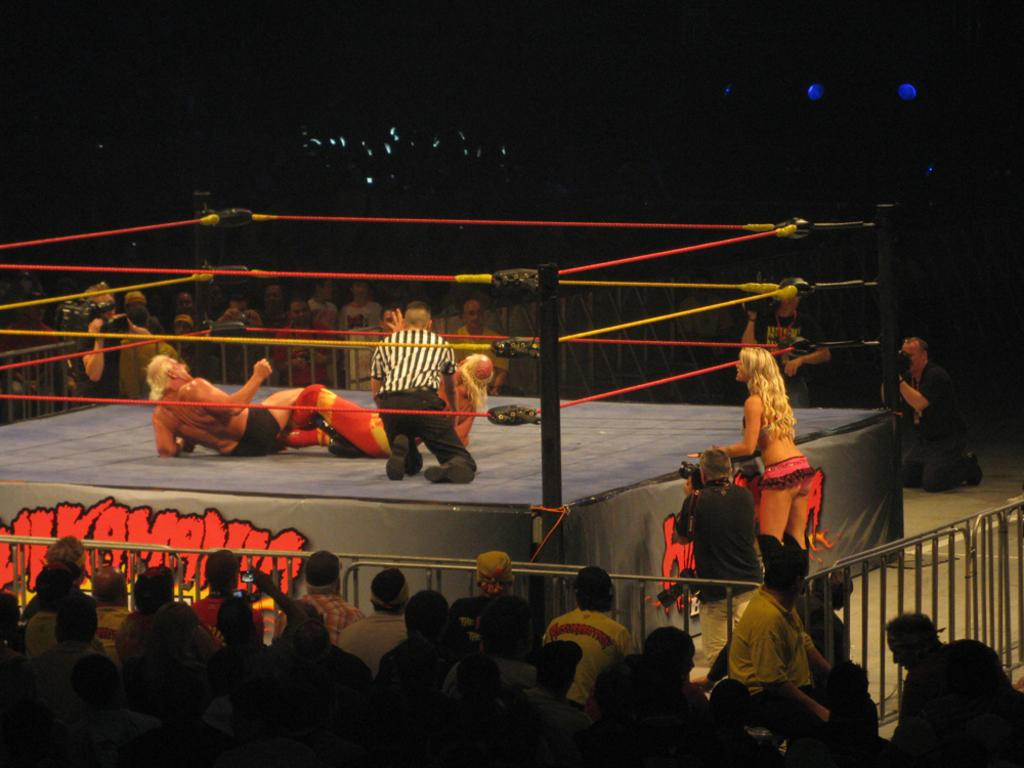Who or what can be seen in the image? There are people in the image. Can you describe the location of some people in the image? Some people are on a stage. What objects are present in the image? There are ropes and railings in the image. How would you describe the lighting in the image? The background of the image is dark. What type of salt can be seen on the railings in the image? There is no salt present in the image, as it only features people, a stage, ropes, and railings. 